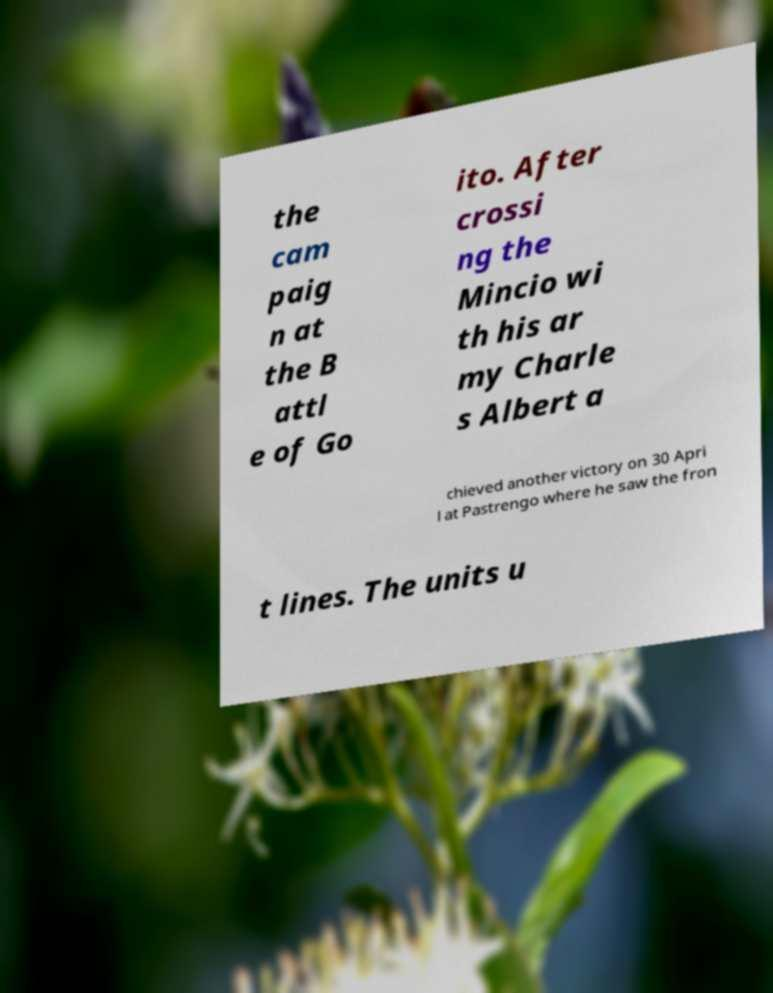I need the written content from this picture converted into text. Can you do that? the cam paig n at the B attl e of Go ito. After crossi ng the Mincio wi th his ar my Charle s Albert a chieved another victory on 30 Apri l at Pastrengo where he saw the fron t lines. The units u 